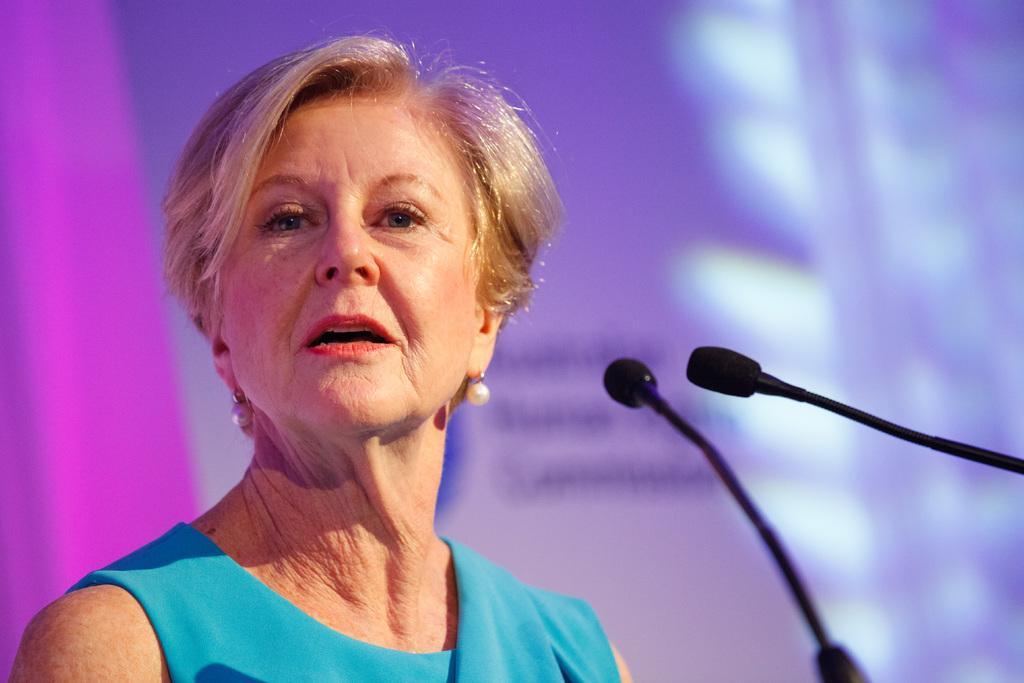How would you summarize this image in a sentence or two? In this image I can see a woman and I can see she is wearing blue colour dress. On the right side of this image I can see few mics. 